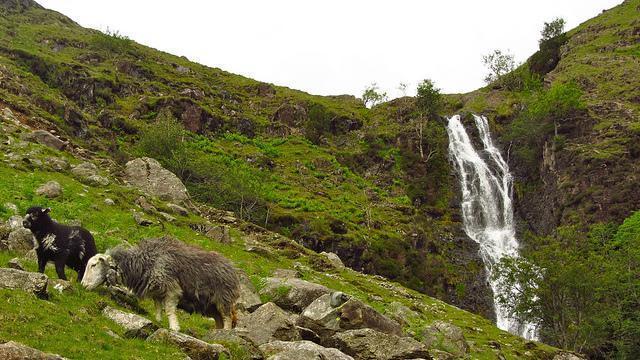How many sheep are there?
Give a very brief answer. 2. How many ovens is there?
Give a very brief answer. 0. 